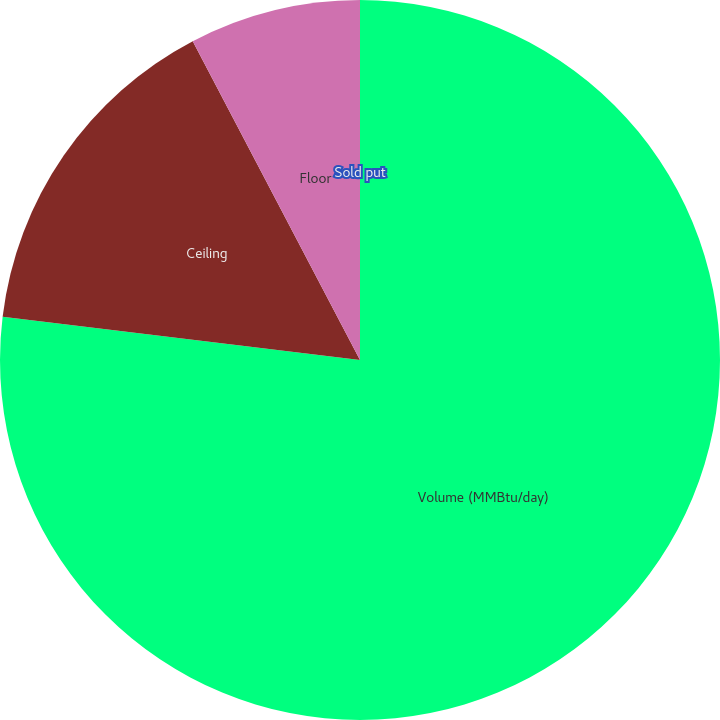Convert chart. <chart><loc_0><loc_0><loc_500><loc_500><pie_chart><fcel>Volume (MMBtu/day)<fcel>Ceiling<fcel>Floor<fcel>Sold put<nl><fcel>76.92%<fcel>15.39%<fcel>7.69%<fcel>0.0%<nl></chart> 